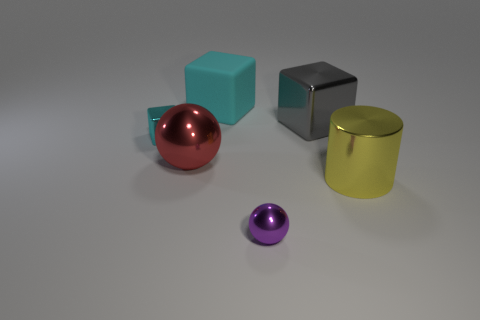There is a tiny thing behind the yellow cylinder; what is its color?
Provide a short and direct response. Cyan. How many other objects are the same color as the matte block?
Your answer should be compact. 1. Are there any other things that have the same size as the gray metal thing?
Keep it short and to the point. Yes. Is the size of the block that is on the right side of the cyan rubber cube the same as the small cyan shiny thing?
Provide a succinct answer. No. What material is the cyan thing that is right of the small cyan metallic cube?
Keep it short and to the point. Rubber. Is there anything else that is the same shape as the big cyan object?
Your answer should be compact. Yes. How many metal things are gray objects or large blue cubes?
Keep it short and to the point. 1. Is the number of tiny purple metallic things behind the big matte block less than the number of large shiny cylinders?
Provide a succinct answer. Yes. What is the shape of the tiny shiny thing on the right side of the tiny metal object that is behind the shiny ball that is left of the cyan matte block?
Give a very brief answer. Sphere. Is the color of the rubber object the same as the large sphere?
Make the answer very short. No. 